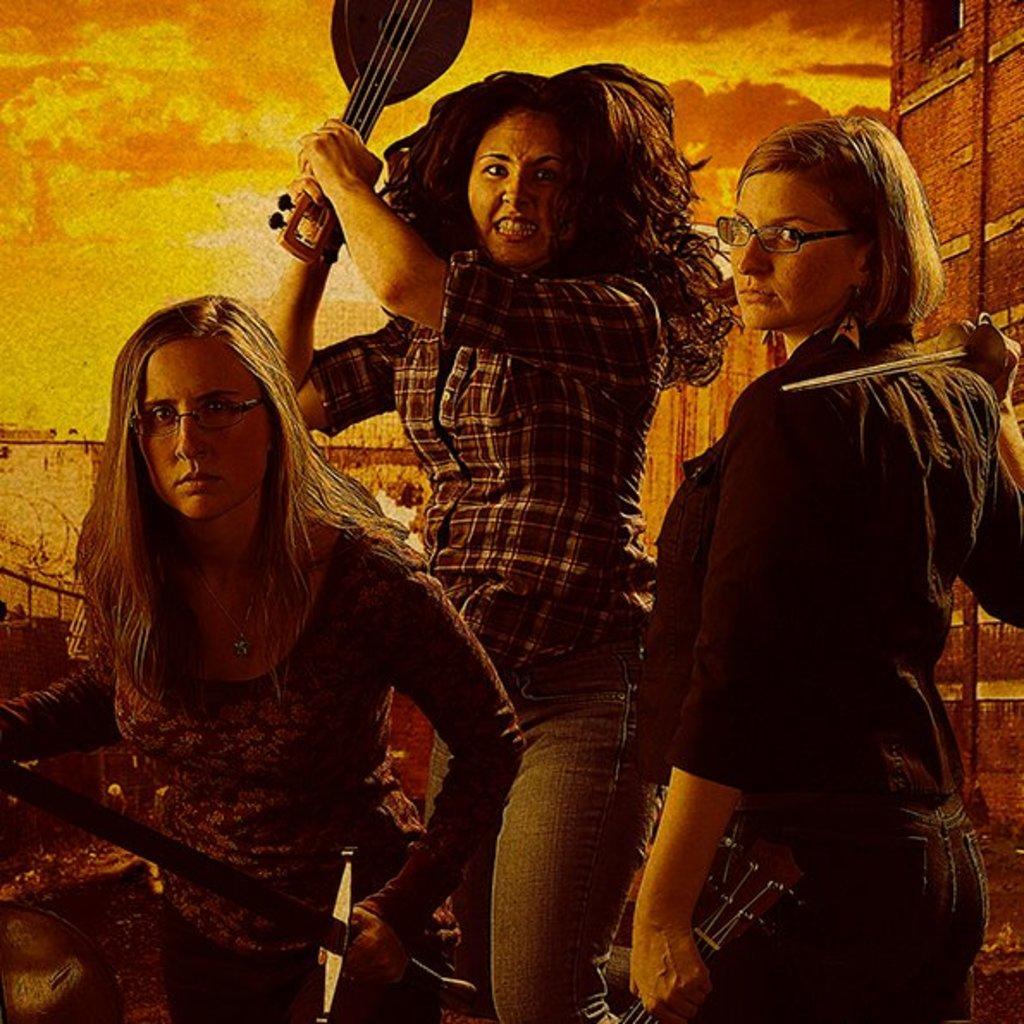Describe this image in one or two sentences. There are three persons. They are standing. They are holding a musical instruments. The two persons are wearing a spectacles. We can see in the background wall. 